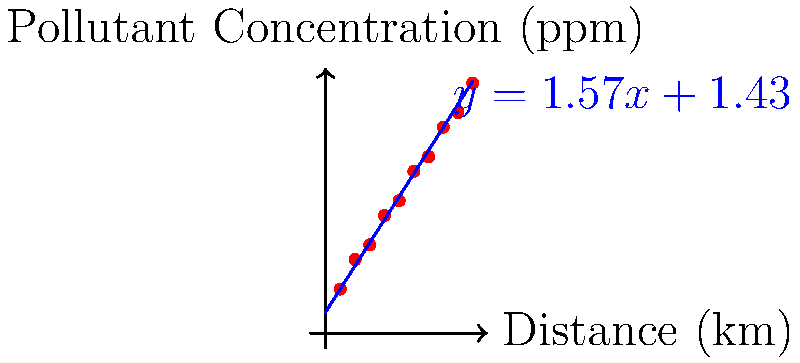Based on the scatter plot and trend line shown, which represents the spread of pollutants from a manufacturing plant, estimate the pollutant concentration at a distance of 12 km from the plant. Round your answer to the nearest whole number. To solve this problem, we'll follow these steps:

1. Identify the equation of the trend line:
   The trend line equation is given as $y = 1.57x + 1.43$, where:
   $y$ represents the pollutant concentration in ppm
   $x$ represents the distance from the plant in km

2. Substitute the given distance into the equation:
   We need to find $y$ when $x = 12$ km
   
   $y = 1.57(12) + 1.43$

3. Calculate the result:
   $y = 18.84 + 1.43$
   $y = 20.27$ ppm

4. Round to the nearest whole number:
   20.27 rounds to 20 ppm

Therefore, at a distance of 12 km from the manufacturing plant, the estimated pollutant concentration is approximately 20 ppm.
Answer: 20 ppm 